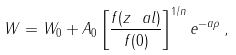Convert formula to latex. <formula><loc_0><loc_0><loc_500><loc_500>W = W _ { 0 } + A _ { 0 } \left [ \frac { f ( z ^ { \ } a l ) } { f ( 0 ) } \right ] ^ { 1 / n } e ^ { - a \rho } \, ,</formula> 